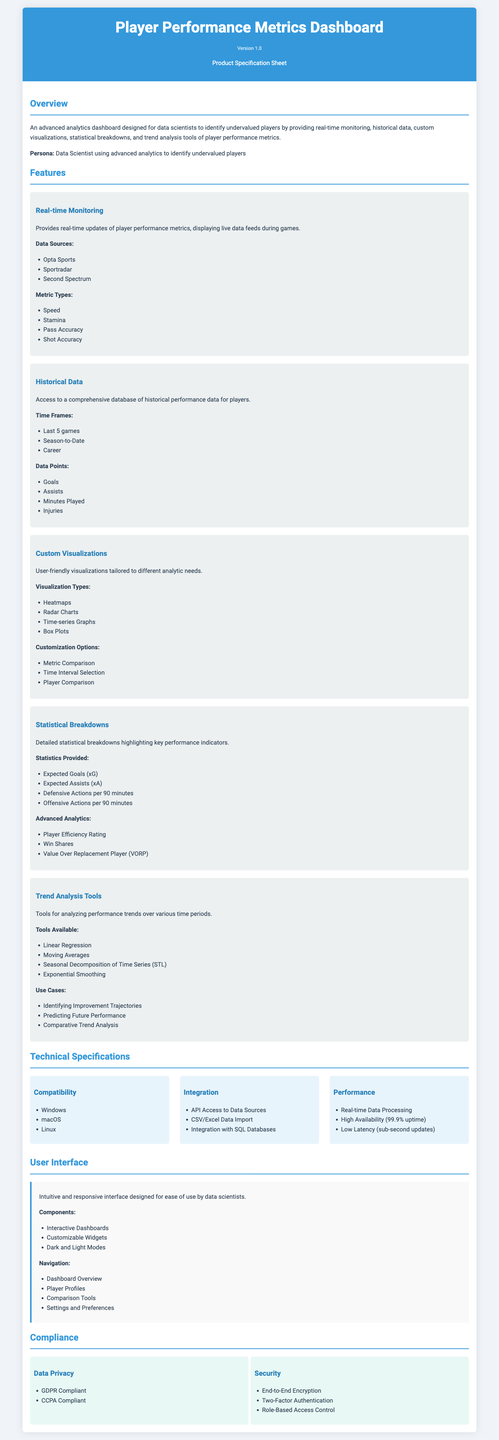What is the product name? The product name is stated at the top of the document.
Answer: Player Performance Metrics Dashboard What version is the specification sheet? The version is indicated in the header of the document.
Answer: Version 1.0 What type of metrics does the dashboard provide? It is mentioned in the overview section.
Answer: Player performance metrics Which data sources are used for real-time monitoring? The data sources are listed under the Real-time Monitoring feature.
Answer: Opta Sports, Sportradar, Second Spectrum What visualization types are available? The visualization types are specified under the Custom Visualizations feature.
Answer: Heatmaps, Radar Charts, Time-series Graphs, Box Plots What is the uptime percentage for performance? The uptime percentage is included in the Technical Specifications section.
Answer: 99.9% uptime What does GDPR stand for? GDPR is mentioned in the Compliance section regarding data privacy.
Answer: General Data Protection Regulation What are the customization options for visualizations? Customization options are listed under the Custom Visualizations feature.
Answer: Metric Comparison, Time Interval Selection, Player Comparison What is one use case of the Trend Analysis Tools? Use cases are outlined in the Trend Analysis Tools feature.
Answer: Identifying Improvement Trajectories 